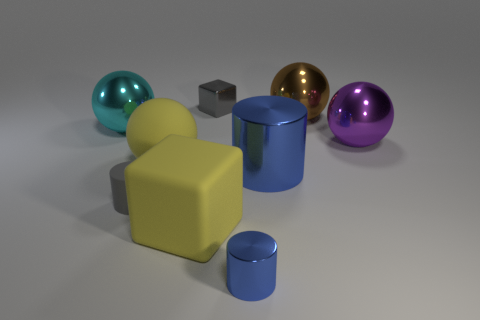What number of big objects are blue metal things or yellow matte spheres? 2 